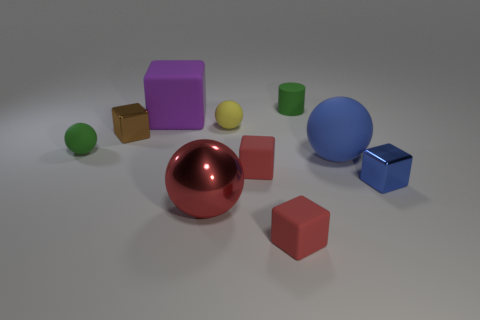How many small matte balls are to the right of the tiny metal object on the right side of the purple cube?
Provide a succinct answer. 0. How many matte balls are both on the right side of the brown metal object and left of the tiny green matte cylinder?
Ensure brevity in your answer.  1. What number of other objects are there of the same material as the small brown block?
Keep it short and to the point. 2. There is a ball that is to the left of the small metallic cube that is on the left side of the blue metallic object; what is its color?
Offer a very short reply. Green. There is a rubber ball that is on the left side of the red sphere; is its color the same as the tiny cylinder?
Provide a short and direct response. Yes. Does the green ball have the same size as the blue shiny thing?
Give a very brief answer. Yes. The blue metallic thing that is the same size as the brown metal cube is what shape?
Give a very brief answer. Cube. There is a metal block left of the green cylinder; is it the same size as the small rubber cylinder?
Your answer should be very brief. Yes. There is a blue object that is the same size as the purple thing; what is it made of?
Ensure brevity in your answer.  Rubber. There is a metal cube on the left side of the matte cube that is behind the brown metal thing; are there any green objects behind it?
Make the answer very short. Yes. 